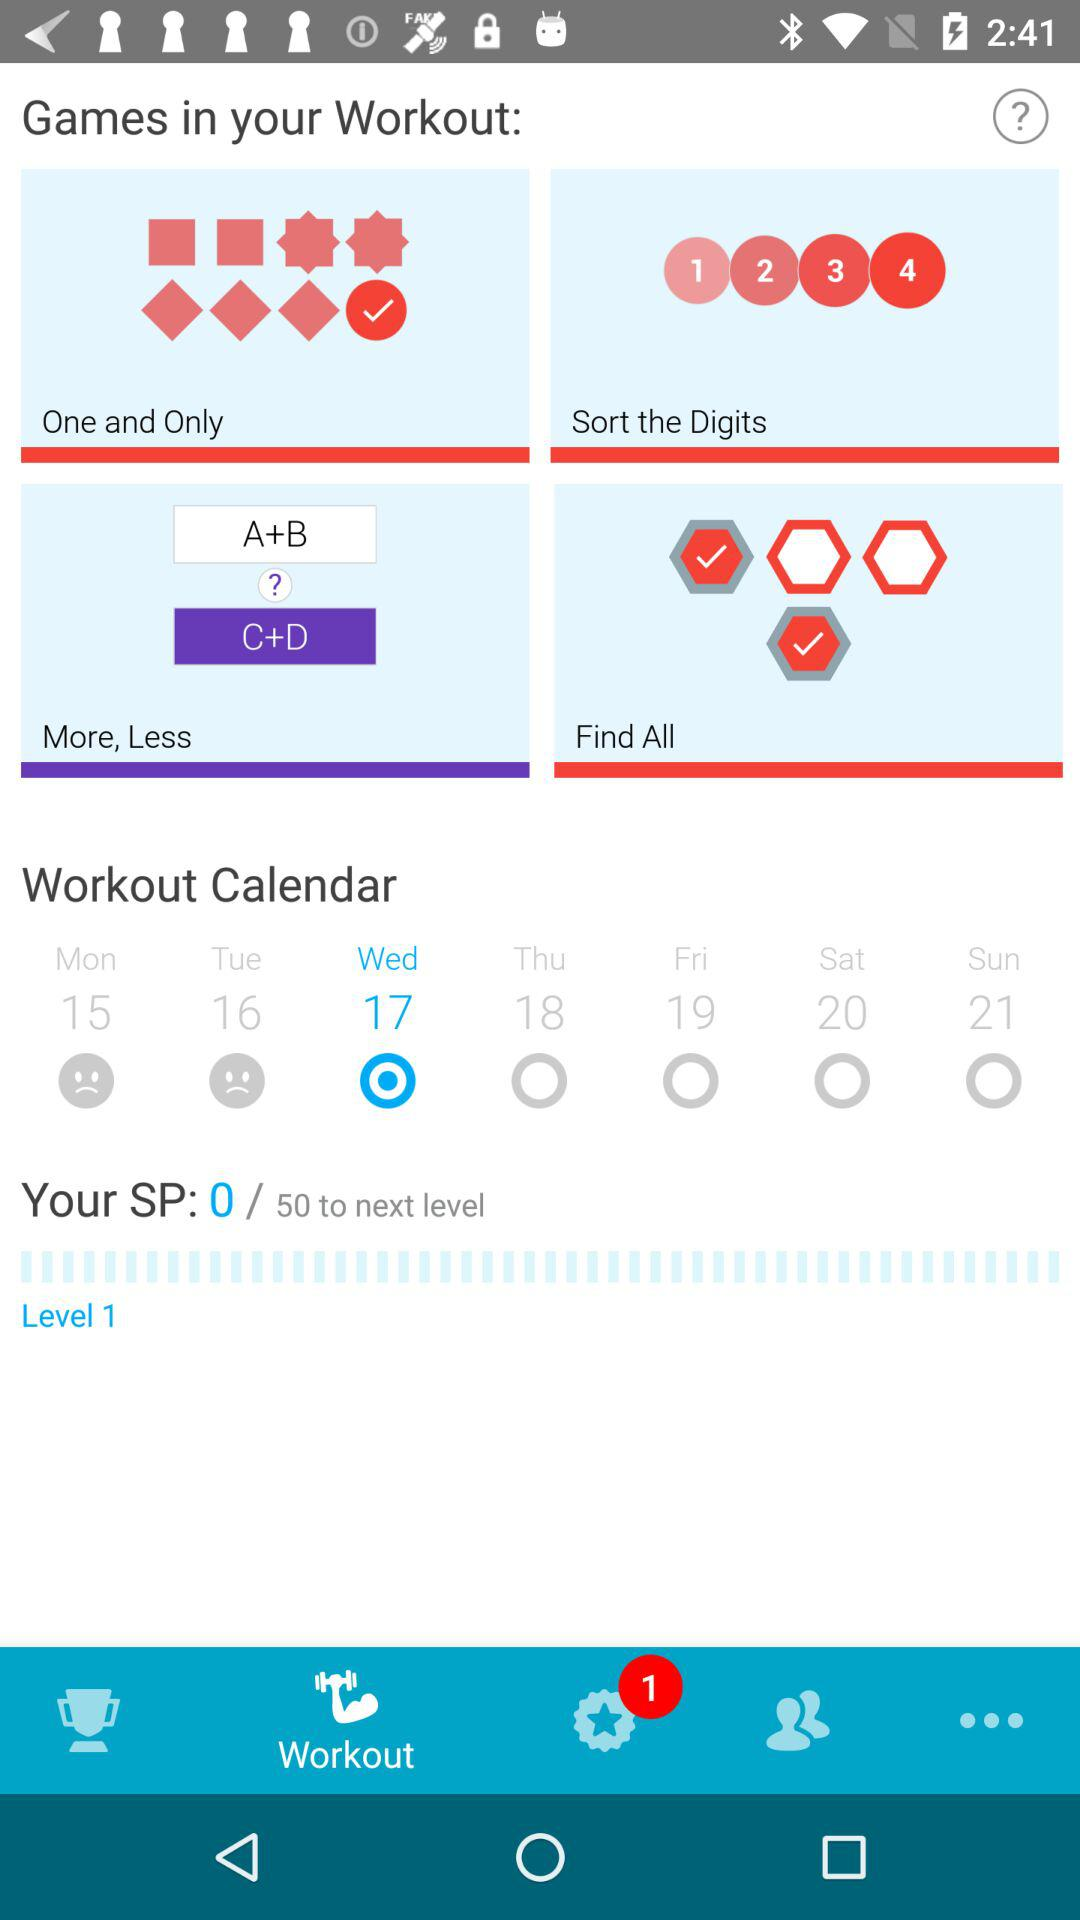How many games have check marks?
Answer the question using a single word or phrase. 2 